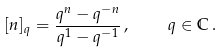Convert formula to latex. <formula><loc_0><loc_0><loc_500><loc_500>[ n ] _ { q } = \frac { q ^ { n } - q ^ { - n } } { q ^ { 1 } - q ^ { - 1 } } \, , \quad q \in \mathbb { C } \, .</formula> 